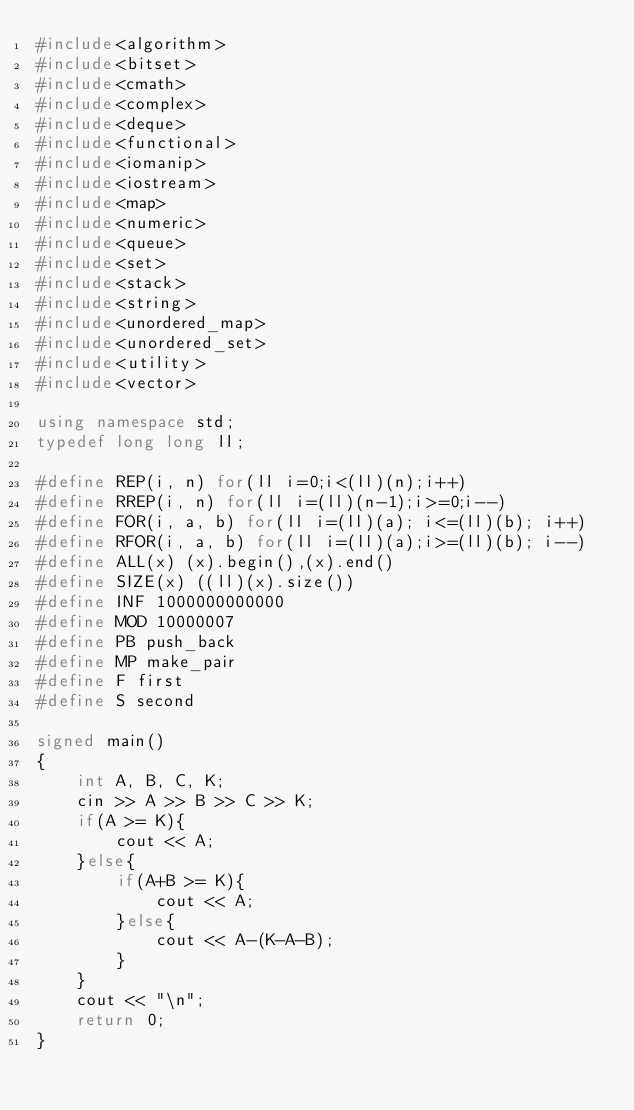<code> <loc_0><loc_0><loc_500><loc_500><_C++_>#include<algorithm>
#include<bitset>
#include<cmath>
#include<complex>
#include<deque>
#include<functional>
#include<iomanip>
#include<iostream>
#include<map>
#include<numeric>
#include<queue>
#include<set>
#include<stack>
#include<string>
#include<unordered_map>
#include<unordered_set>
#include<utility>
#include<vector>

using namespace std;
typedef long long ll;

#define REP(i, n) for(ll i=0;i<(ll)(n);i++)
#define RREP(i, n) for(ll i=(ll)(n-1);i>=0;i--)
#define FOR(i, a, b) for(ll i=(ll)(a); i<=(ll)(b); i++)
#define RFOR(i, a, b) for(ll i=(ll)(a);i>=(ll)(b); i--)
#define ALL(x) (x).begin(),(x).end()
#define SIZE(x) ((ll)(x).size())
#define INF 1000000000000
#define MOD 10000007
#define PB push_back
#define MP make_pair
#define F first
#define S second

signed main()
{
	int A, B, C, K;
	cin >> A >> B >> C >> K;
	if(A >= K){
		cout << A;
	}else{
		if(A+B >= K){
			cout << A;
		}else{
			cout << A-(K-A-B);
		}
	}
	cout << "\n";
	return 0;
}
</code> 